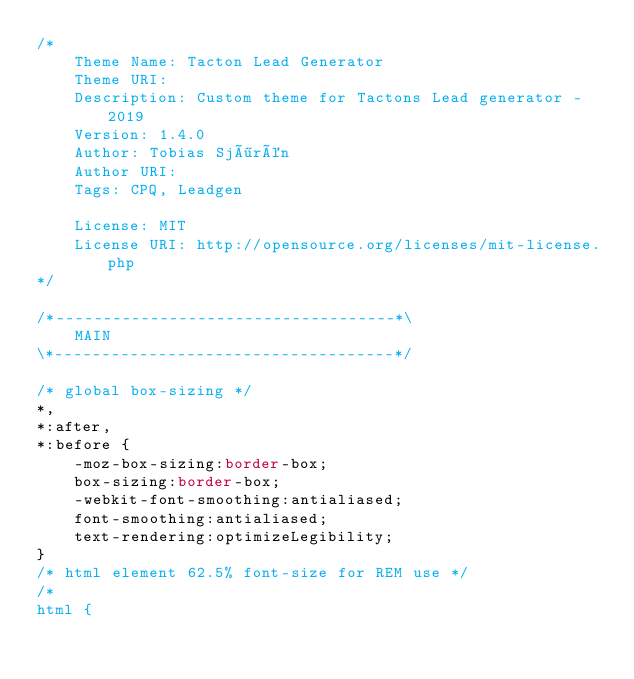Convert code to text. <code><loc_0><loc_0><loc_500><loc_500><_CSS_>/*
	Theme Name: Tacton Lead Generator
	Theme URI: 
	Description: Custom theme for Tactons Lead generator - 2019
	Version: 1.4.0
	Author: Tobias Sjörén
	Author URI: 
	Tags: CPQ, Leadgen

	License: MIT
	License URI: http://opensource.org/licenses/mit-license.php
*/

/*------------------------------------*\
    MAIN
\*------------------------------------*/

/* global box-sizing */
*,
*:after,
*:before {
	-moz-box-sizing:border-box;
	box-sizing:border-box;
	-webkit-font-smoothing:antialiased;
	font-smoothing:antialiased;
	text-rendering:optimizeLegibility;
}
/* html element 62.5% font-size for REM use */
/*
html {</code> 